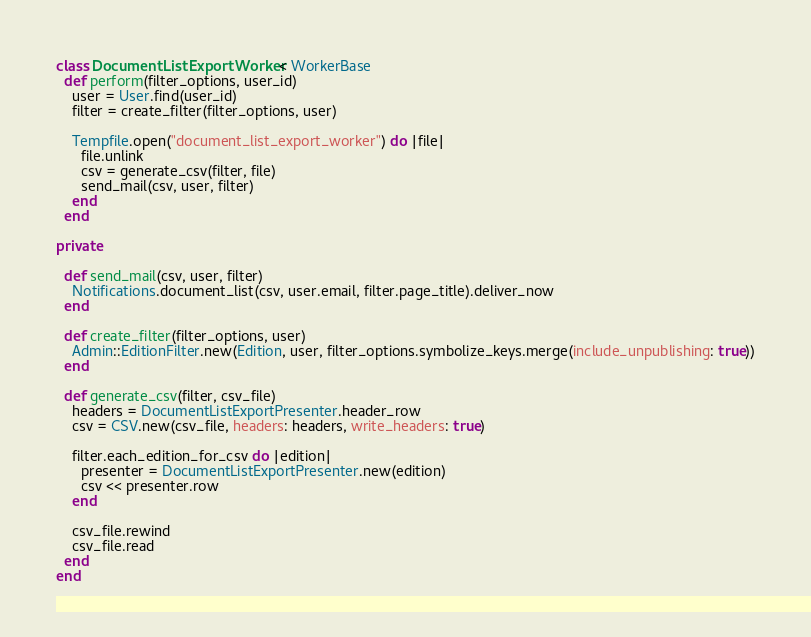Convert code to text. <code><loc_0><loc_0><loc_500><loc_500><_Ruby_>class DocumentListExportWorker < WorkerBase
  def perform(filter_options, user_id)
    user = User.find(user_id)
    filter = create_filter(filter_options, user)

    Tempfile.open("document_list_export_worker") do |file|
      file.unlink
      csv = generate_csv(filter, file)
      send_mail(csv, user, filter)
    end
  end

private

  def send_mail(csv, user, filter)
    Notifications.document_list(csv, user.email, filter.page_title).deliver_now
  end

  def create_filter(filter_options, user)
    Admin::EditionFilter.new(Edition, user, filter_options.symbolize_keys.merge(include_unpublishing: true))
  end

  def generate_csv(filter, csv_file)
    headers = DocumentListExportPresenter.header_row
    csv = CSV.new(csv_file, headers: headers, write_headers: true)

    filter.each_edition_for_csv do |edition|
      presenter = DocumentListExportPresenter.new(edition)
      csv << presenter.row
    end

    csv_file.rewind
    csv_file.read
  end
end
</code> 